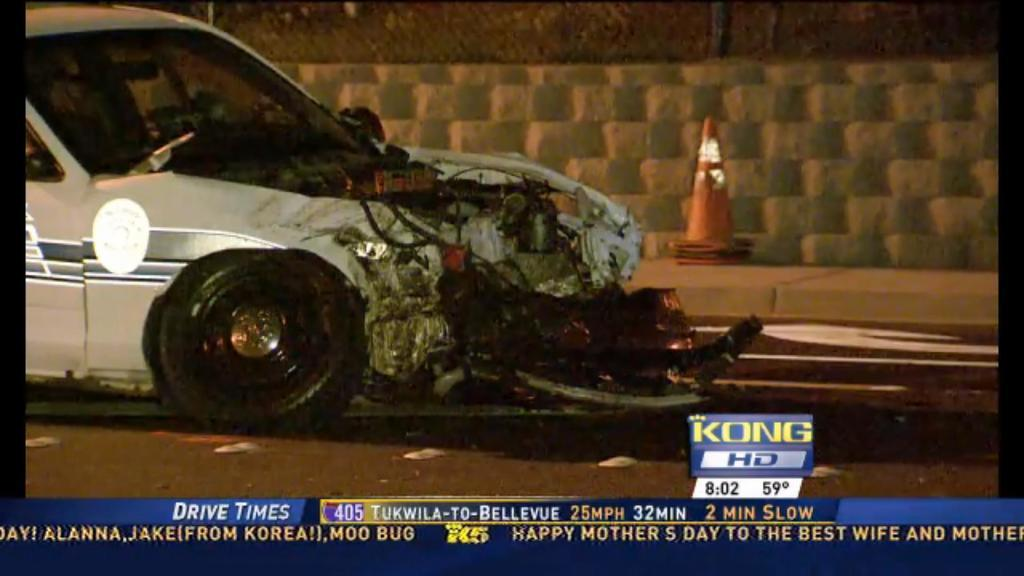<image>
Summarize the visual content of the image. A wrecked car with the caption Drive Times. 